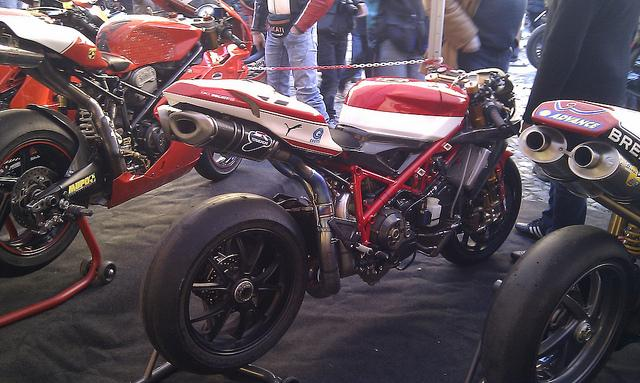What type of vehicle are these? motorcycles 